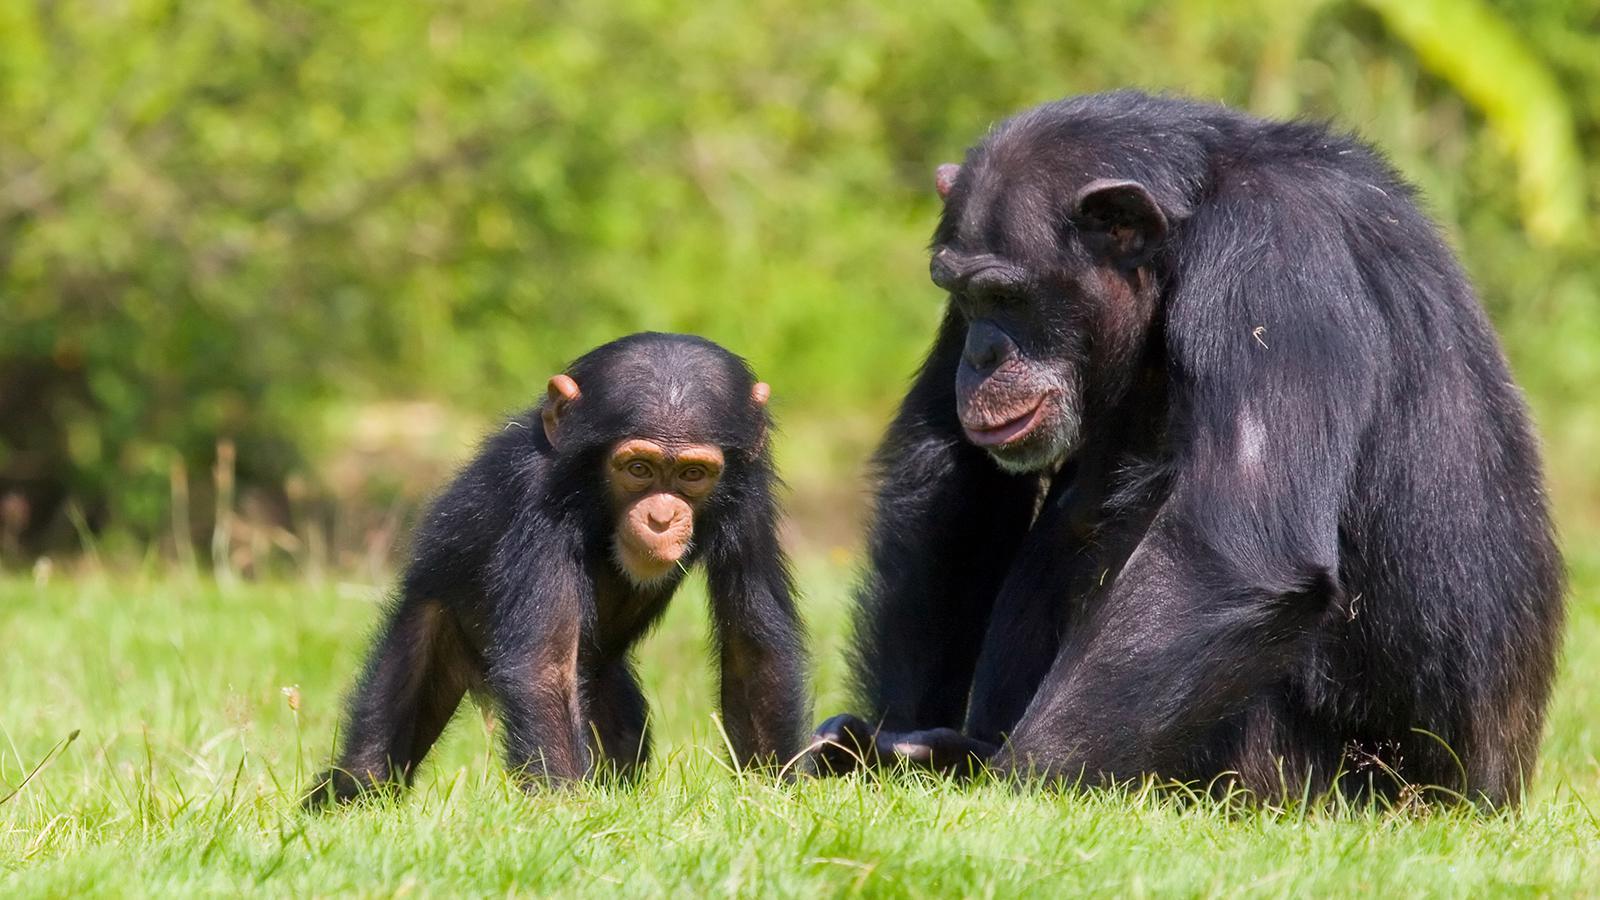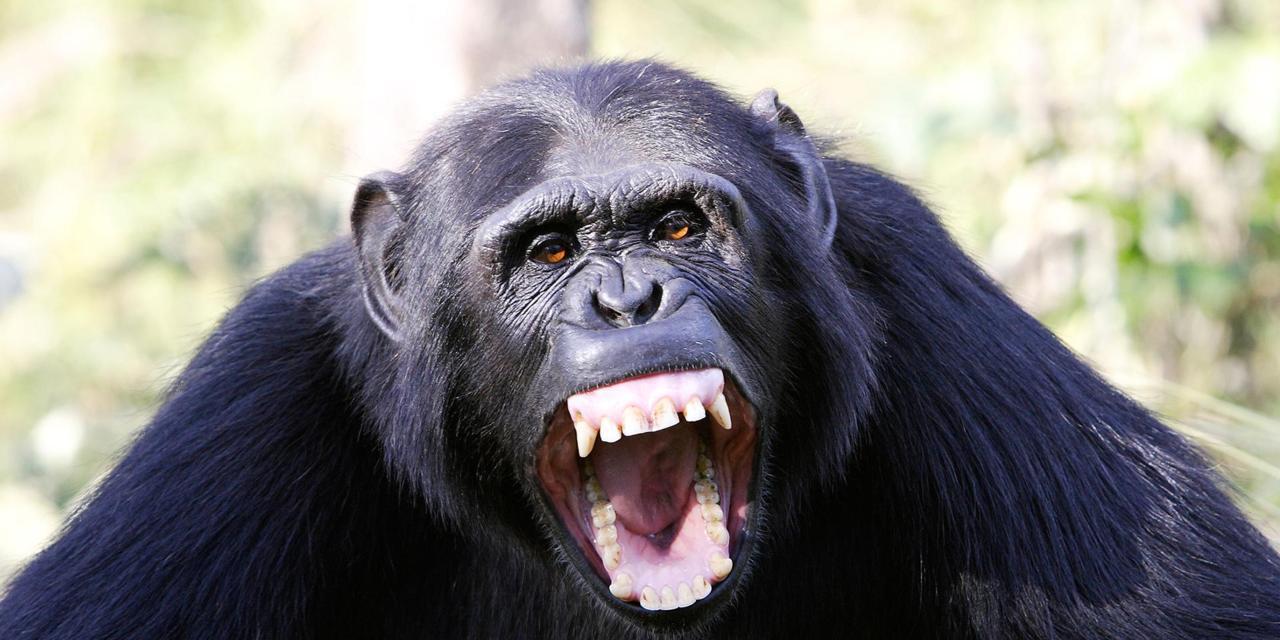The first image is the image on the left, the second image is the image on the right. For the images displayed, is the sentence "There is exactly one baby monkey in the image on the right." factually correct? Answer yes or no. No. The first image is the image on the left, the second image is the image on the right. Analyze the images presented: Is the assertion "An image shows at least one young chimp with an older chimp nearby." valid? Answer yes or no. Yes. The first image is the image on the left, the second image is the image on the right. Assess this claim about the two images: "Just one adult and one young chimp are interacting side-by-side in the left image.". Correct or not? Answer yes or no. Yes. 